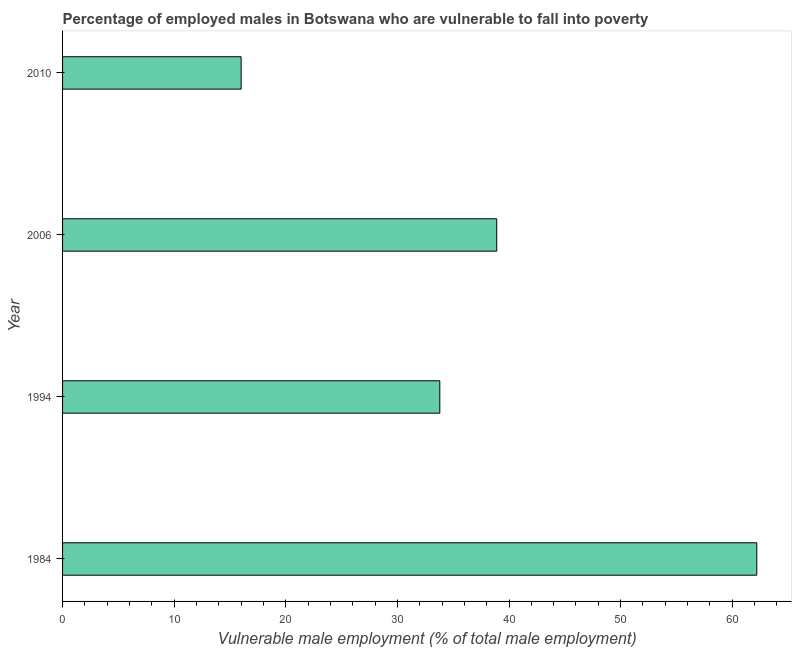Does the graph contain any zero values?
Provide a short and direct response. No. Does the graph contain grids?
Your answer should be compact. No. What is the title of the graph?
Your answer should be compact. Percentage of employed males in Botswana who are vulnerable to fall into poverty. What is the label or title of the X-axis?
Offer a very short reply. Vulnerable male employment (% of total male employment). What is the label or title of the Y-axis?
Provide a succinct answer. Year. What is the percentage of employed males who are vulnerable to fall into poverty in 1994?
Make the answer very short. 33.8. Across all years, what is the maximum percentage of employed males who are vulnerable to fall into poverty?
Offer a terse response. 62.2. In which year was the percentage of employed males who are vulnerable to fall into poverty minimum?
Your answer should be compact. 2010. What is the sum of the percentage of employed males who are vulnerable to fall into poverty?
Provide a succinct answer. 150.9. What is the difference between the percentage of employed males who are vulnerable to fall into poverty in 1984 and 2010?
Provide a succinct answer. 46.2. What is the average percentage of employed males who are vulnerable to fall into poverty per year?
Give a very brief answer. 37.73. What is the median percentage of employed males who are vulnerable to fall into poverty?
Your response must be concise. 36.35. In how many years, is the percentage of employed males who are vulnerable to fall into poverty greater than 14 %?
Provide a short and direct response. 4. What is the ratio of the percentage of employed males who are vulnerable to fall into poverty in 1994 to that in 2006?
Provide a succinct answer. 0.87. Is the percentage of employed males who are vulnerable to fall into poverty in 1984 less than that in 2006?
Your response must be concise. No. What is the difference between the highest and the second highest percentage of employed males who are vulnerable to fall into poverty?
Keep it short and to the point. 23.3. Is the sum of the percentage of employed males who are vulnerable to fall into poverty in 1984 and 1994 greater than the maximum percentage of employed males who are vulnerable to fall into poverty across all years?
Your answer should be very brief. Yes. What is the difference between the highest and the lowest percentage of employed males who are vulnerable to fall into poverty?
Give a very brief answer. 46.2. Are all the bars in the graph horizontal?
Make the answer very short. Yes. What is the Vulnerable male employment (% of total male employment) of 1984?
Provide a succinct answer. 62.2. What is the Vulnerable male employment (% of total male employment) of 1994?
Keep it short and to the point. 33.8. What is the Vulnerable male employment (% of total male employment) in 2006?
Your response must be concise. 38.9. What is the Vulnerable male employment (% of total male employment) in 2010?
Ensure brevity in your answer.  16. What is the difference between the Vulnerable male employment (% of total male employment) in 1984 and 1994?
Provide a short and direct response. 28.4. What is the difference between the Vulnerable male employment (% of total male employment) in 1984 and 2006?
Your answer should be very brief. 23.3. What is the difference between the Vulnerable male employment (% of total male employment) in 1984 and 2010?
Make the answer very short. 46.2. What is the difference between the Vulnerable male employment (% of total male employment) in 2006 and 2010?
Your response must be concise. 22.9. What is the ratio of the Vulnerable male employment (% of total male employment) in 1984 to that in 1994?
Your response must be concise. 1.84. What is the ratio of the Vulnerable male employment (% of total male employment) in 1984 to that in 2006?
Ensure brevity in your answer.  1.6. What is the ratio of the Vulnerable male employment (% of total male employment) in 1984 to that in 2010?
Ensure brevity in your answer.  3.89. What is the ratio of the Vulnerable male employment (% of total male employment) in 1994 to that in 2006?
Keep it short and to the point. 0.87. What is the ratio of the Vulnerable male employment (% of total male employment) in 1994 to that in 2010?
Your response must be concise. 2.11. What is the ratio of the Vulnerable male employment (% of total male employment) in 2006 to that in 2010?
Your answer should be compact. 2.43. 